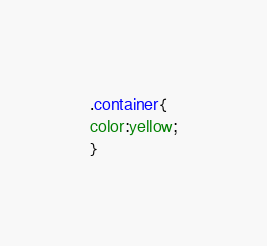Convert code to text. <code><loc_0><loc_0><loc_500><loc_500><_CSS_>.container{
color:yellow;
}</code> 